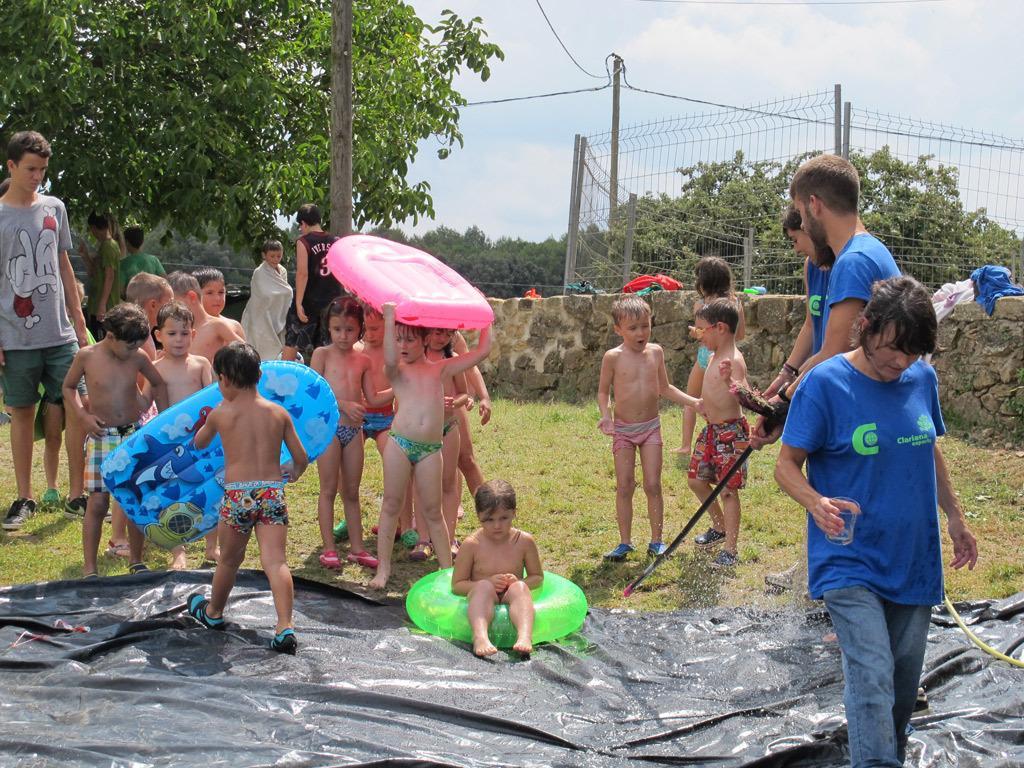In one or two sentences, can you explain what this image depicts? In this image we can see persons. We can also see the kids standing on the grass. There is a girl sitting. We can also see the safety ring and some other objects. In the background we can see the trees, fence, pole and also the wall and some clothes. Sky is also visible with the clouds. At the bottom we can see the black color cover. 